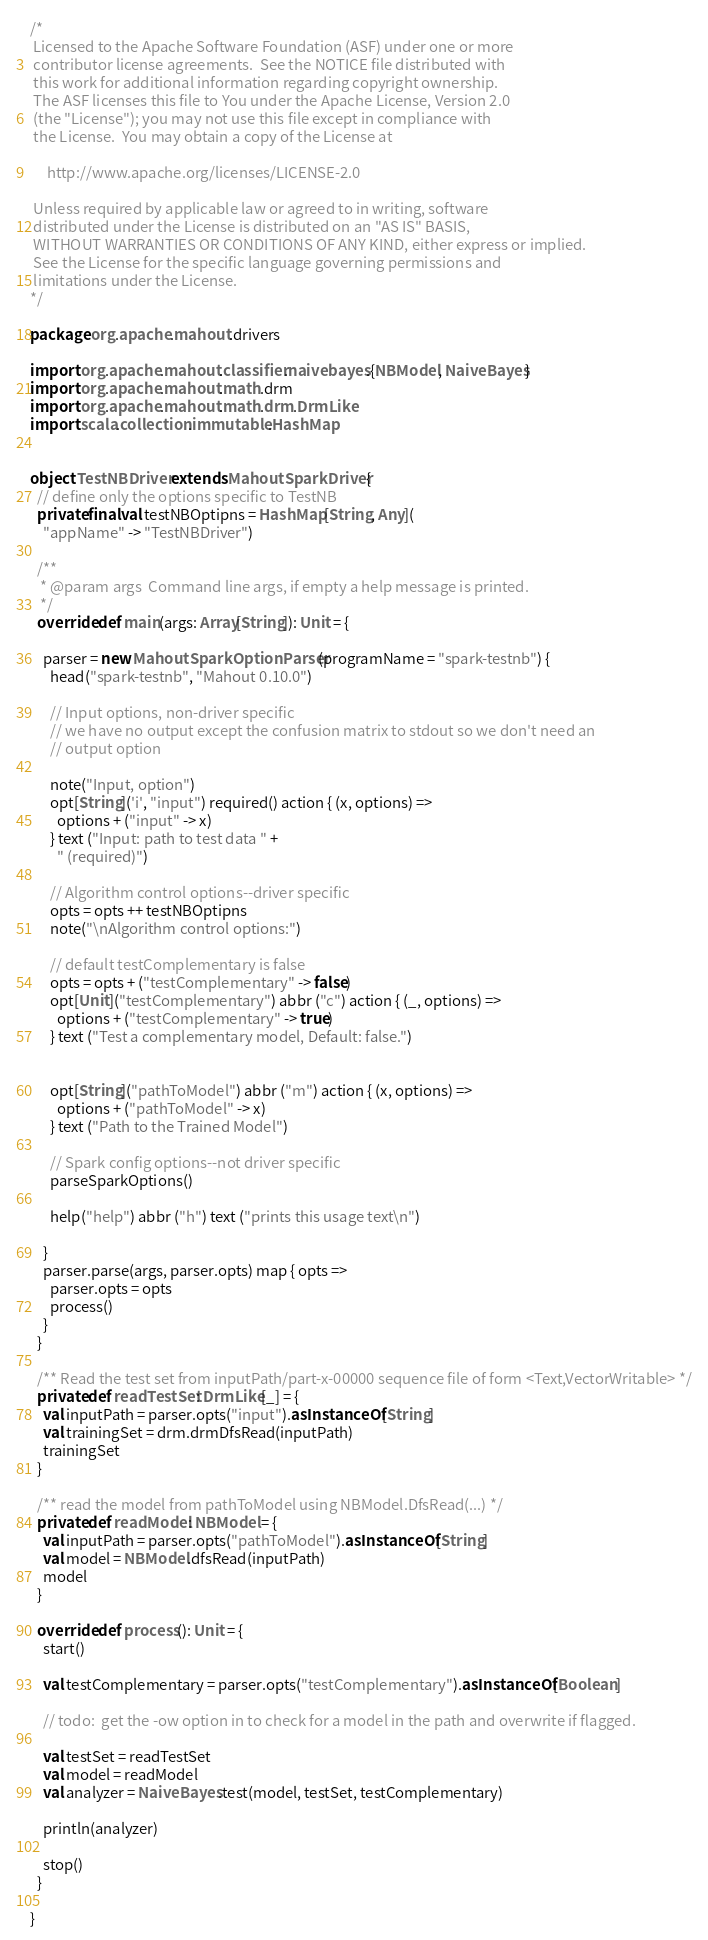Convert code to text. <code><loc_0><loc_0><loc_500><loc_500><_Scala_>/*
 Licensed to the Apache Software Foundation (ASF) under one or more
 contributor license agreements.  See the NOTICE file distributed with
 this work for additional information regarding copyright ownership.
 The ASF licenses this file to You under the Apache License, Version 2.0
 (the "License"); you may not use this file except in compliance with
 the License.  You may obtain a copy of the License at

     http://www.apache.org/licenses/LICENSE-2.0

 Unless required by applicable law or agreed to in writing, software
 distributed under the License is distributed on an "AS IS" BASIS,
 WITHOUT WARRANTIES OR CONDITIONS OF ANY KIND, either express or implied.
 See the License for the specific language governing permissions and
 limitations under the License.
*/

package org.apache.mahout.drivers

import org.apache.mahout.classifier.naivebayes.{NBModel, NaiveBayes}
import org.apache.mahout.math.drm
import org.apache.mahout.math.drm.DrmLike
import scala.collection.immutable.HashMap


object TestNBDriver extends MahoutSparkDriver {
  // define only the options specific to TestNB
  private final val testNBOptipns = HashMap[String, Any](
    "appName" -> "TestNBDriver")

  /**
   * @param args  Command line args, if empty a help message is printed.
   */
  override def main(args: Array[String]): Unit = {

    parser = new MahoutSparkOptionParser(programName = "spark-testnb") {
      head("spark-testnb", "Mahout 0.10.0")

      // Input options, non-driver specific
      // we have no output except the confusion matrix to stdout so we don't need an
      // output option

      note("Input, option")
      opt[String]('i', "input") required() action { (x, options) =>
        options + ("input" -> x)
      } text ("Input: path to test data " +
        " (required)")

      // Algorithm control options--driver specific
      opts = opts ++ testNBOptipns
      note("\nAlgorithm control options:")

      // default testComplementary is false
      opts = opts + ("testComplementary" -> false)
      opt[Unit]("testComplementary") abbr ("c") action { (_, options) =>
        options + ("testComplementary" -> true)
      } text ("Test a complementary model, Default: false.")


      opt[String]("pathToModel") abbr ("m") action { (x, options) =>
        options + ("pathToModel" -> x)
      } text ("Path to the Trained Model")

      // Spark config options--not driver specific
      parseSparkOptions()

      help("help") abbr ("h") text ("prints this usage text\n")

    }
    parser.parse(args, parser.opts) map { opts =>
      parser.opts = opts
      process()
    }
  }

  /** Read the test set from inputPath/part-x-00000 sequence file of form <Text,VectorWritable> */
  private def readTestSet: DrmLike[_] = {
    val inputPath = parser.opts("input").asInstanceOf[String]
    val trainingSet = drm.drmDfsRead(inputPath)
    trainingSet
  }

  /** read the model from pathToModel using NBModel.DfsRead(...) */
  private def readModel: NBModel = {
    val inputPath = parser.opts("pathToModel").asInstanceOf[String]
    val model = NBModel.dfsRead(inputPath)
    model
  }

  override def process(): Unit = {
    start()

    val testComplementary = parser.opts("testComplementary").asInstanceOf[Boolean]

    // todo:  get the -ow option in to check for a model in the path and overwrite if flagged.

    val testSet = readTestSet
    val model = readModel
    val analyzer = NaiveBayes.test(model, testSet, testComplementary)

    println(analyzer)

    stop()
  }

}

</code> 